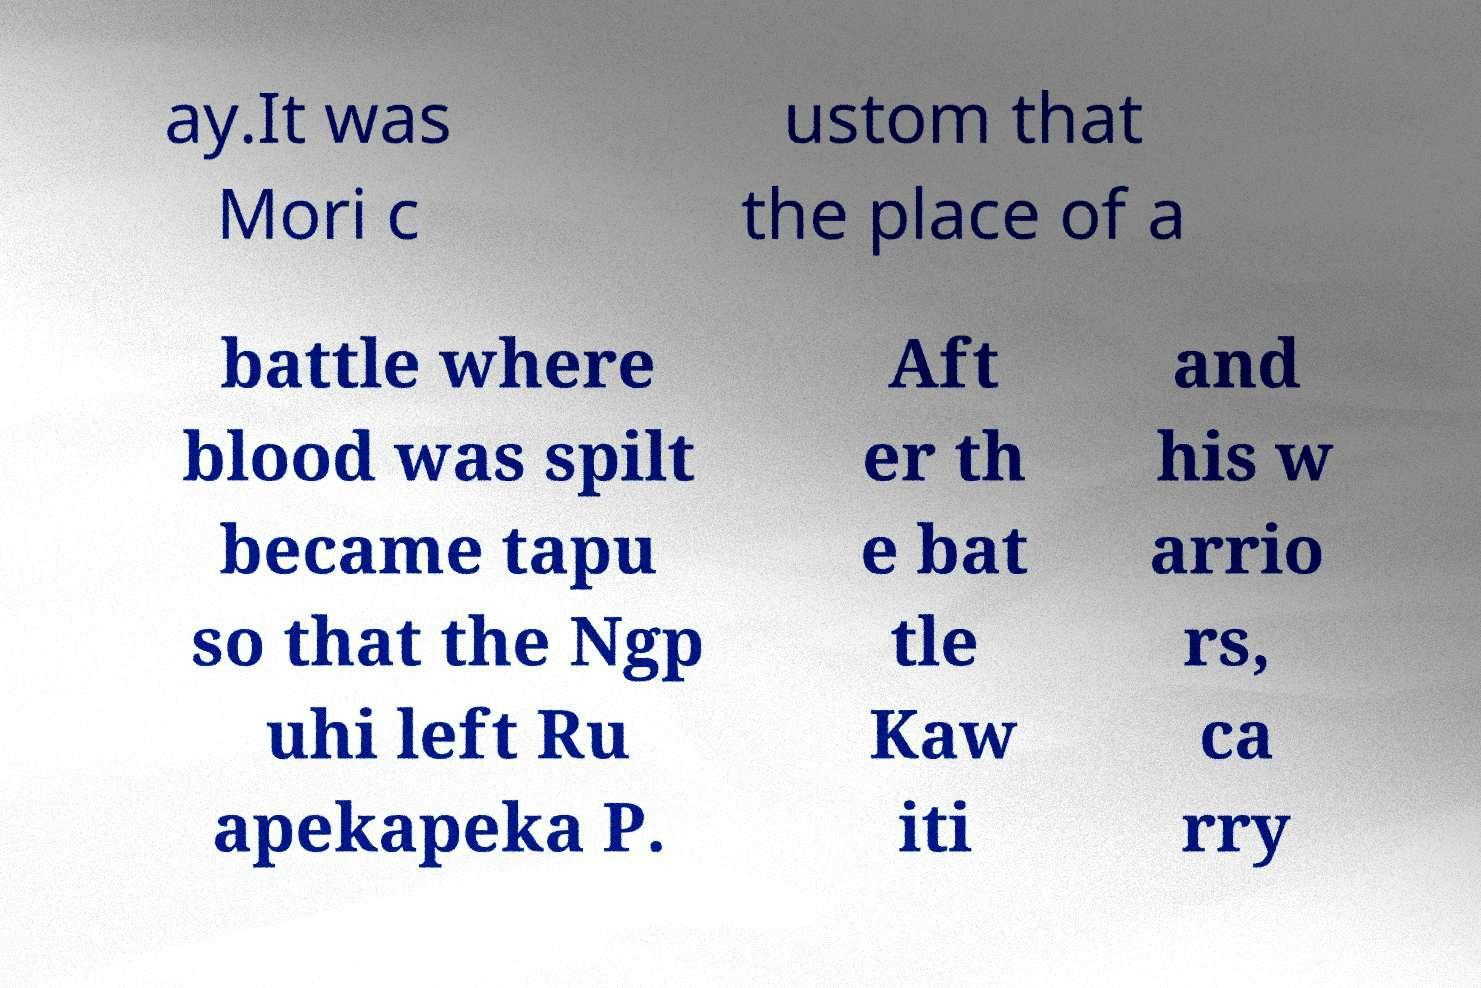For documentation purposes, I need the text within this image transcribed. Could you provide that? ay.It was Mori c ustom that the place of a battle where blood was spilt became tapu so that the Ngp uhi left Ru apekapeka P. Aft er th e bat tle Kaw iti and his w arrio rs, ca rry 